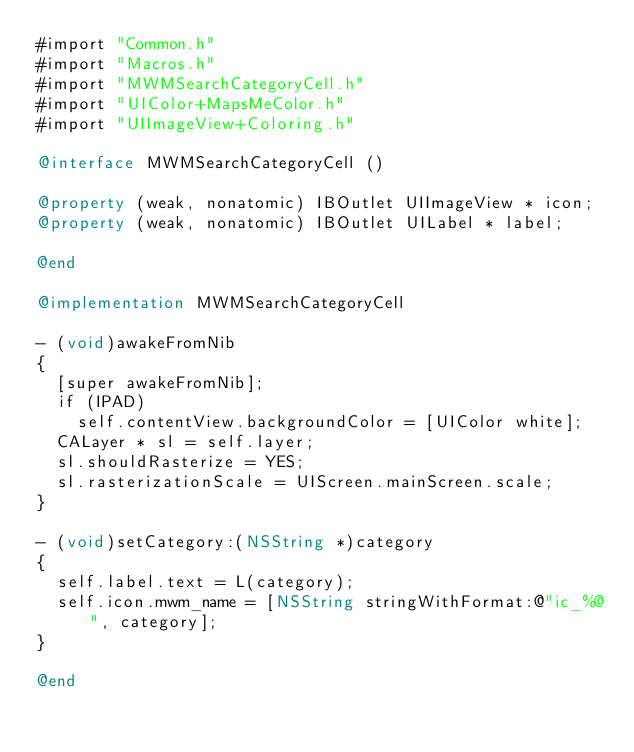Convert code to text. <code><loc_0><loc_0><loc_500><loc_500><_ObjectiveC_>#import "Common.h"
#import "Macros.h"
#import "MWMSearchCategoryCell.h"
#import "UIColor+MapsMeColor.h"
#import "UIImageView+Coloring.h"

@interface MWMSearchCategoryCell ()

@property (weak, nonatomic) IBOutlet UIImageView * icon;
@property (weak, nonatomic) IBOutlet UILabel * label;

@end

@implementation MWMSearchCategoryCell

- (void)awakeFromNib
{
  [super awakeFromNib];
  if (IPAD)
    self.contentView.backgroundColor = [UIColor white];
  CALayer * sl = self.layer;
  sl.shouldRasterize = YES;
  sl.rasterizationScale = UIScreen.mainScreen.scale;
}

- (void)setCategory:(NSString *)category
{
  self.label.text = L(category);
  self.icon.mwm_name = [NSString stringWithFormat:@"ic_%@", category];
}

@end
</code> 